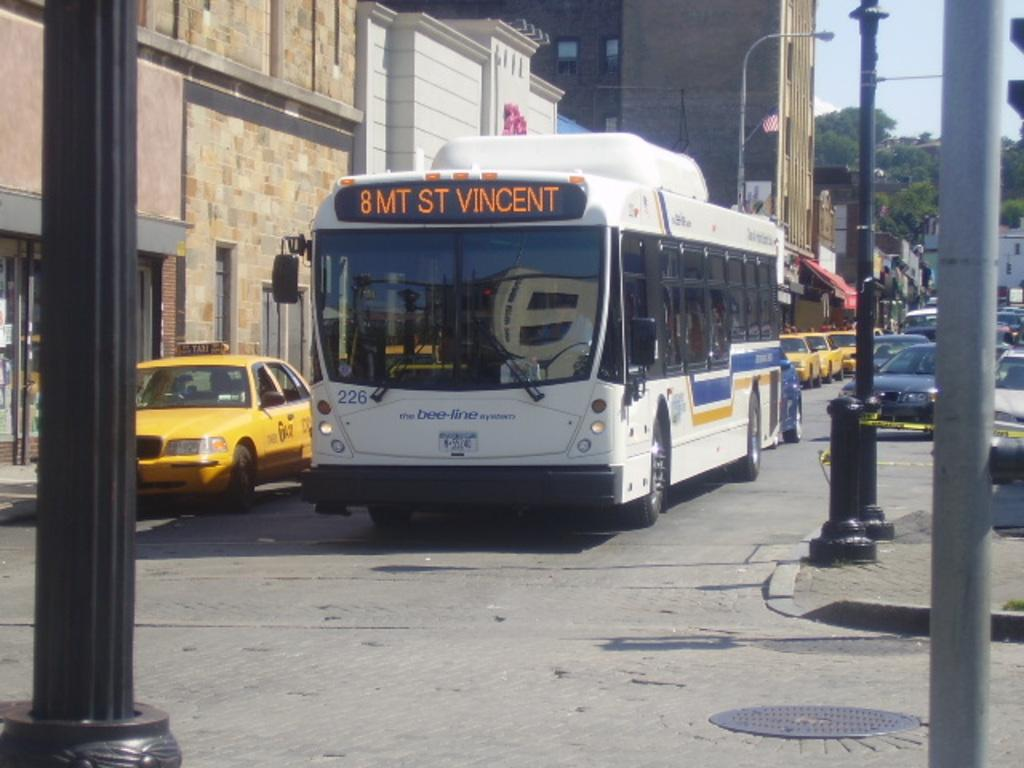<image>
Offer a succinct explanation of the picture presented. A white, blue and gold bus whose rout is going to st vincent. 